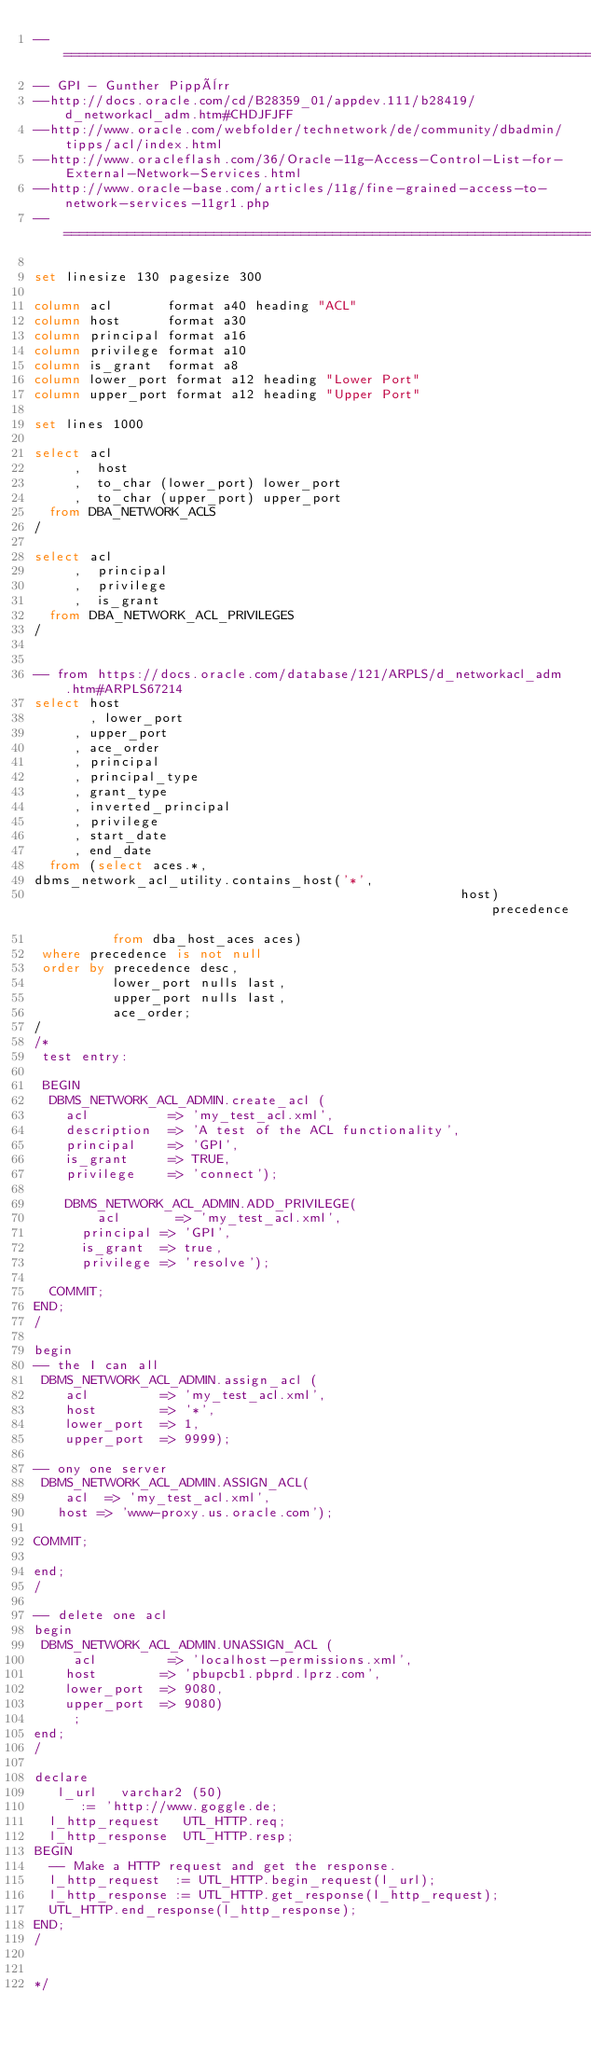Convert code to text. <code><loc_0><loc_0><loc_500><loc_500><_SQL_>--===============================================================================
-- GPI - Gunther Pippèrr
--http://docs.oracle.com/cd/B28359_01/appdev.111/b28419/d_networkacl_adm.htm#CHDJFJFF
--http://www.oracle.com/webfolder/technetwork/de/community/dbadmin/tipps/acl/index.html
--http://www.oracleflash.com/36/Oracle-11g-Access-Control-List-for-External-Network-Services.html
--http://www.oracle-base.com/articles/11g/fine-grained-access-to-network-services-11gr1.php
--===============================================================================

set linesize 130 pagesize 300 

column acl       format a40 heading "ACL"
column host      format a30
column principal format a16
column privilege format a10
column is_grant  format a8
column lower_port format a12 heading "Lower Port"
column upper_port format a12 heading "Upper Port"

set lines 1000

select acl
     ,  host
     ,  to_char (lower_port) lower_port
     ,  to_char (upper_port) upper_port
  from DBA_NETWORK_ACLS
/

select acl
     ,  principal
     ,  privilege
     ,  is_grant
  from DBA_NETWORK_ACL_PRIVILEGES
/


-- from https://docs.oracle.com/database/121/ARPLS/d_networkacl_adm.htm#ARPLS67214
select host
       , lower_port
	   , upper_port
	   , ace_order
	   , principal
	   , principal_type
	   , grant_type
	   , inverted_principal
	   , privilege
	   , start_date
	   , end_date
  from (select aces.*,
dbms_network_acl_utility.contains_host('*',
                                                      host) precedence
          from dba_host_aces aces)
 where precedence is not null
 order by precedence desc,
          lower_port nulls last,
          upper_port nulls last,
          ace_order;
/
/*
 test entry:
 
 BEGIN
  DBMS_NETWORK_ACL_ADMIN.create_acl (
    acl          => 'my_test_acl.xml', 
    description  => 'A test of the ACL functionality',
    principal    => 'GPI',
    is_grant     => TRUE, 
    privilege    => 'connect');   
     
    DBMS_NETWORK_ACL_ADMIN.ADD_PRIVILEGE(
        acl       => 'my_test_acl.xml',
      principal => 'GPI',
      is_grant  => true,
      privilege => 'resolve');
        
  COMMIT;
END;
/

begin
-- the I can all
 DBMS_NETWORK_ACL_ADMIN.assign_acl (
    acl         => 'my_test_acl.xml',
    host        => '*', 
    lower_port  => 1,
    upper_port  => 9999); 

-- ony one server     
 DBMS_NETWORK_ACL_ADMIN.ASSIGN_ACL(
    acl  => 'my_test_acl.xml',
   host => 'www-proxy.us.oracle.com');

COMMIT;

end;
/     

-- delete one acl
begin
 DBMS_NETWORK_ACL_ADMIN.UNASSIGN_ACL (
     acl         => 'localhost-permissions.xml',
    host        => 'pbupcb1.pbprd.lprz.com', 
    lower_port  => 9080,     
    upper_port  => 9080)
     ; 
end;
/        

declare
   l_url   varchar2 (50)
      := 'http://www.goggle.de;
  l_http_request   UTL_HTTP.req;
  l_http_response  UTL_HTTP.resp;
BEGIN
  -- Make a HTTP request and get the response.
  l_http_request  := UTL_HTTP.begin_request(l_url);
  l_http_response := UTL_HTTP.get_response(l_http_request);  
  UTL_HTTP.end_response(l_http_response);
END;
/


*/</code> 